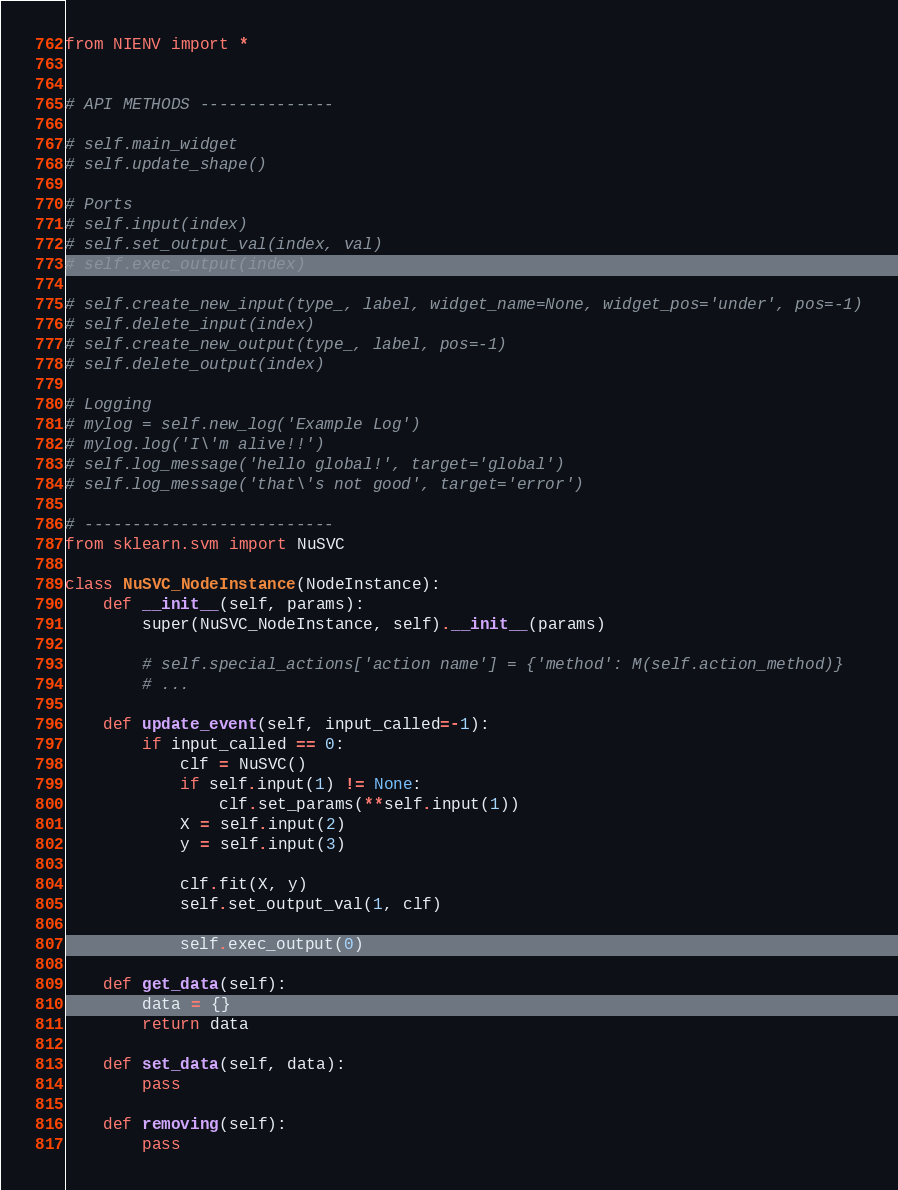<code> <loc_0><loc_0><loc_500><loc_500><_Python_>from NIENV import *


# API METHODS --------------

# self.main_widget
# self.update_shape()

# Ports
# self.input(index)
# self.set_output_val(index, val)
# self.exec_output(index)

# self.create_new_input(type_, label, widget_name=None, widget_pos='under', pos=-1)
# self.delete_input(index)
# self.create_new_output(type_, label, pos=-1)
# self.delete_output(index)

# Logging
# mylog = self.new_log('Example Log')
# mylog.log('I\'m alive!!')
# self.log_message('hello global!', target='global')
# self.log_message('that\'s not good', target='error')

# --------------------------
from sklearn.svm import NuSVC

class NuSVC_NodeInstance(NodeInstance):
    def __init__(self, params):
        super(NuSVC_NodeInstance, self).__init__(params)

        # self.special_actions['action name'] = {'method': M(self.action_method)}
        # ...

    def update_event(self, input_called=-1):
        if input_called == 0:
            clf = NuSVC()
            if self.input(1) != None:
                clf.set_params(**self.input(1))
            X = self.input(2)
            y = self.input(3)

            clf.fit(X, y)
            self.set_output_val(1, clf)

            self.exec_output(0)

    def get_data(self):
        data = {}
        return data

    def set_data(self, data):
        pass

    def removing(self):
        pass
</code> 